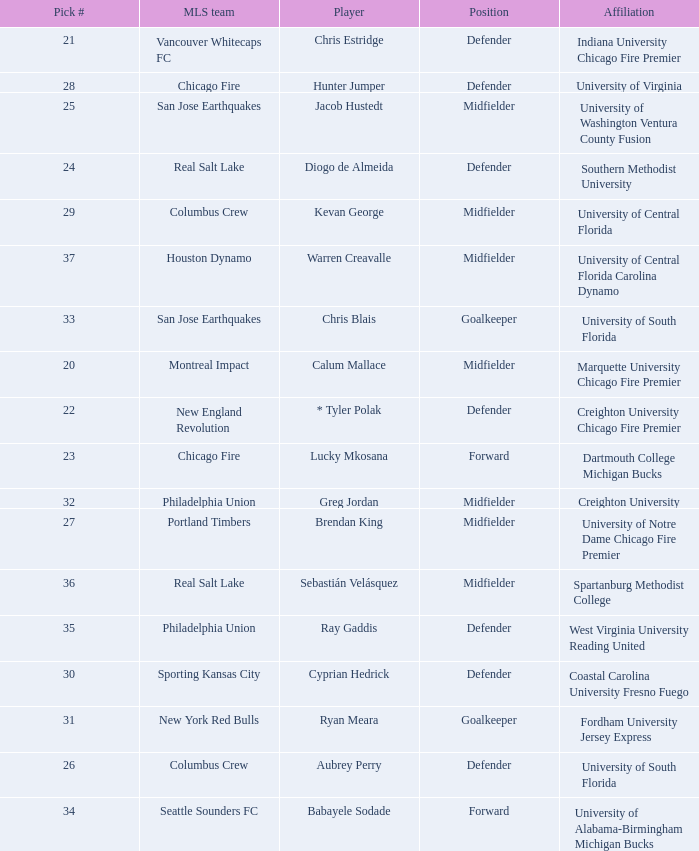What university was Kevan George affiliated with? University of Central Florida. 